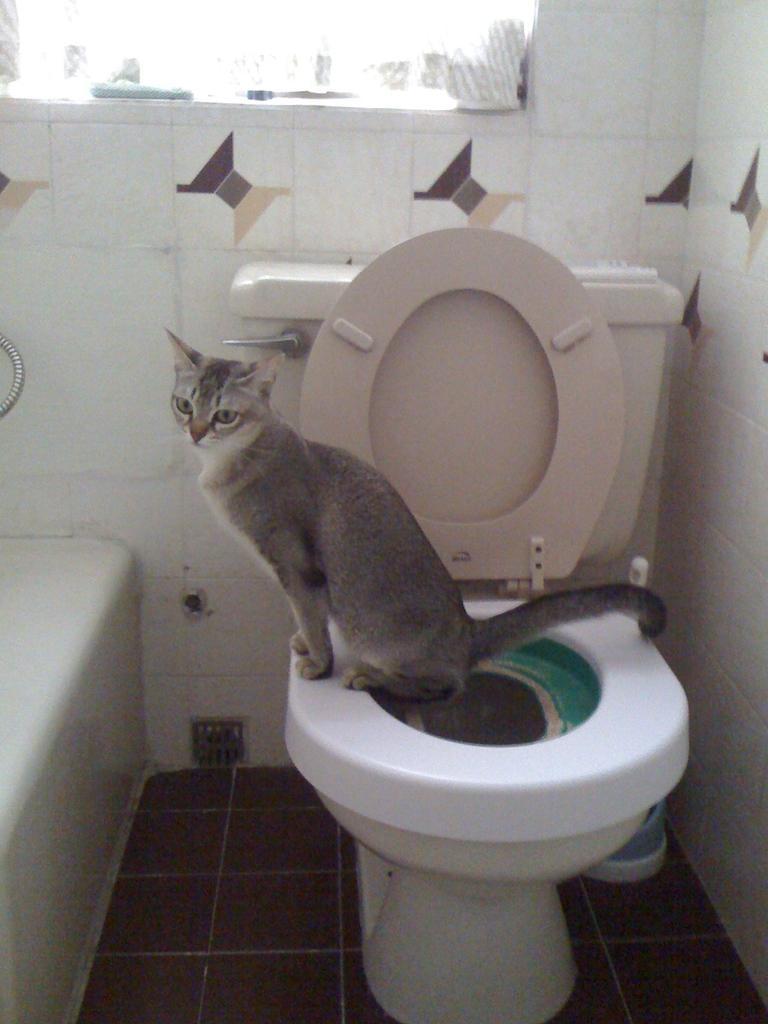Describe this image in one or two sentences. In this picture there is a cat on the toilet seat. At the back there are objects on the wall and there is a window. At the bottom there is an object on the floor. On the left side of the image it looks like a bathtub. 